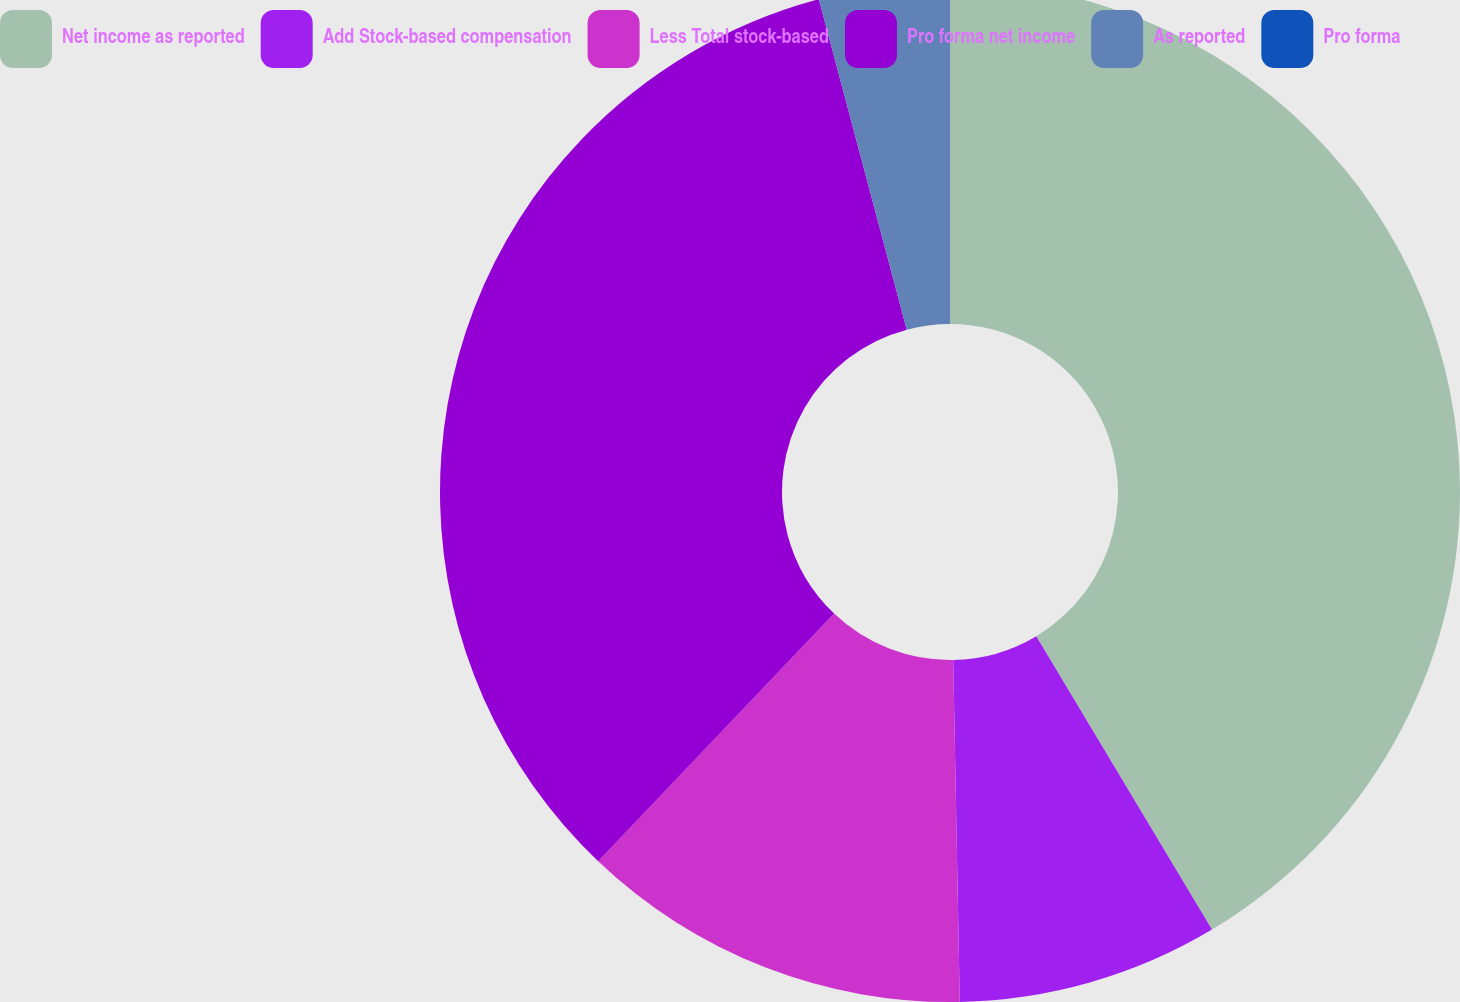Convert chart. <chart><loc_0><loc_0><loc_500><loc_500><pie_chart><fcel>Net income as reported<fcel>Add Stock-based compensation<fcel>Less Total stock-based<fcel>Pro forma net income<fcel>As reported<fcel>Pro forma<nl><fcel>41.41%<fcel>8.28%<fcel>12.42%<fcel>33.74%<fcel>4.14%<fcel>0.0%<nl></chart> 